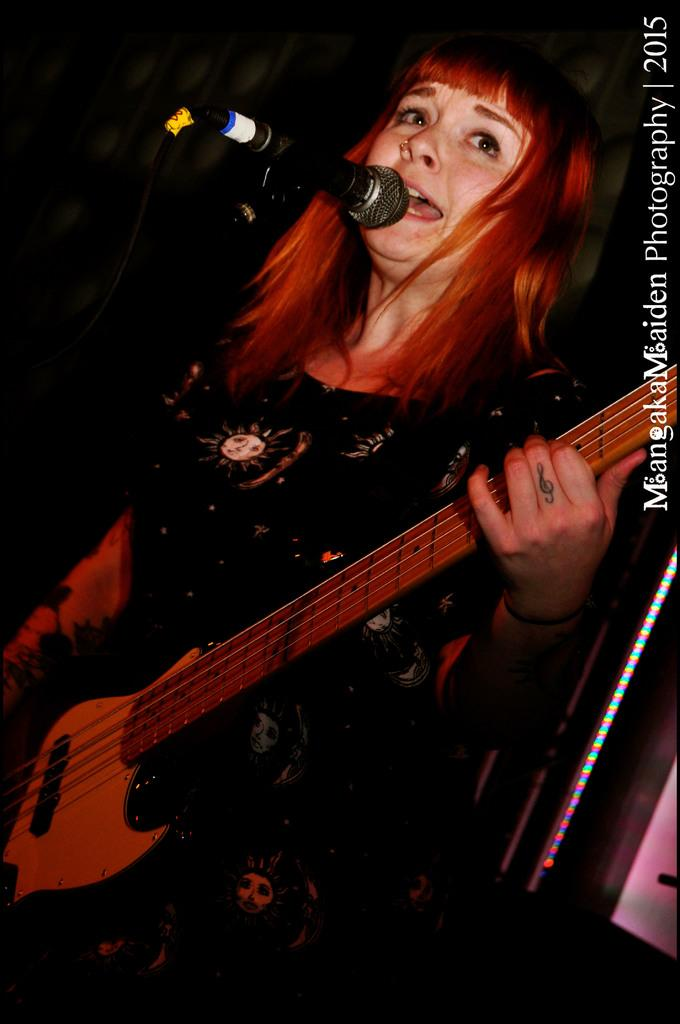Who is the main subject in the image? There is a woman in the image. What is the woman doing in the image? The woman is standing, playing a guitar, and singing into a microphone. What type of question is the woman asking the audience in the image? There is no indication in the image that the woman is asking a question; she is playing a guitar and singing into a microphone. 